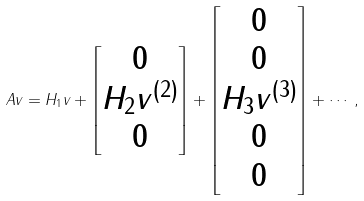<formula> <loc_0><loc_0><loc_500><loc_500>A v = H _ { 1 } v + \begin{bmatrix} 0 \\ H _ { 2 } v ^ { ( 2 ) } \\ 0 \end{bmatrix} + \begin{bmatrix} 0 \\ 0 \\ H _ { 3 } v ^ { ( 3 ) } \\ 0 \\ 0 \end{bmatrix} + \cdots ,</formula> 